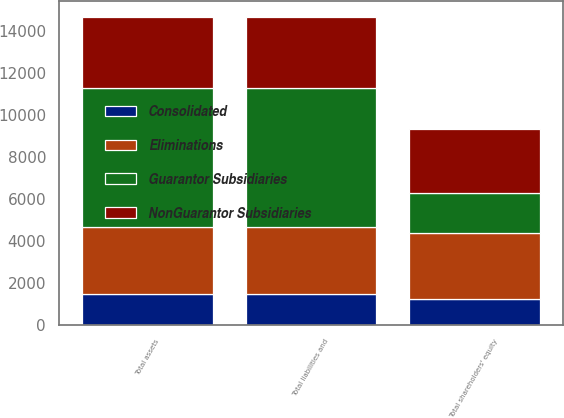Convert chart to OTSL. <chart><loc_0><loc_0><loc_500><loc_500><stacked_bar_chart><ecel><fcel>Total assets<fcel>Total shareholders' equity<fcel>Total liabilities and<nl><fcel>NonGuarantor Subsidiaries<fcel>3414<fcel>3026<fcel>3414<nl><fcel>Guarantor Subsidiaries<fcel>6610<fcel>1913<fcel>6610<nl><fcel>Consolidated<fcel>1508<fcel>1241<fcel>1508<nl><fcel>Eliminations<fcel>3154<fcel>3154<fcel>3154<nl></chart> 